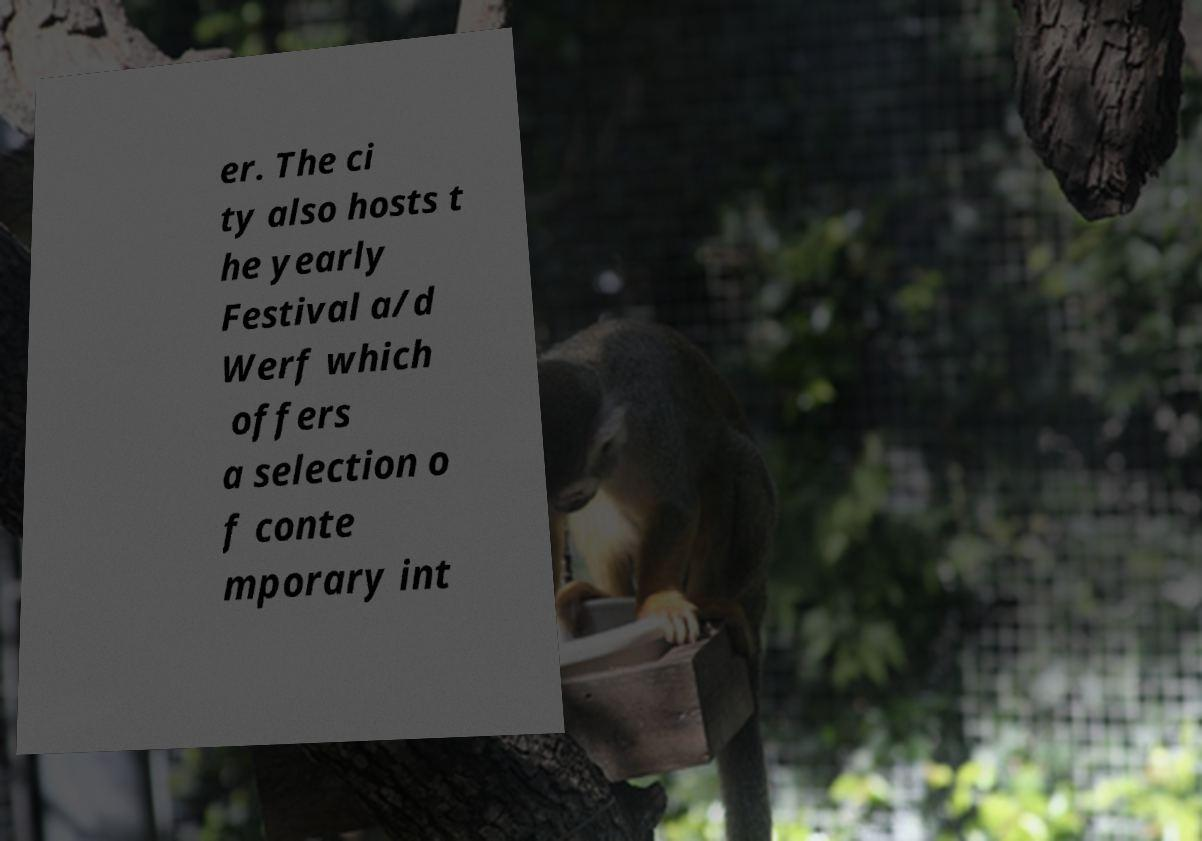Could you extract and type out the text from this image? er. The ci ty also hosts t he yearly Festival a/d Werf which offers a selection o f conte mporary int 